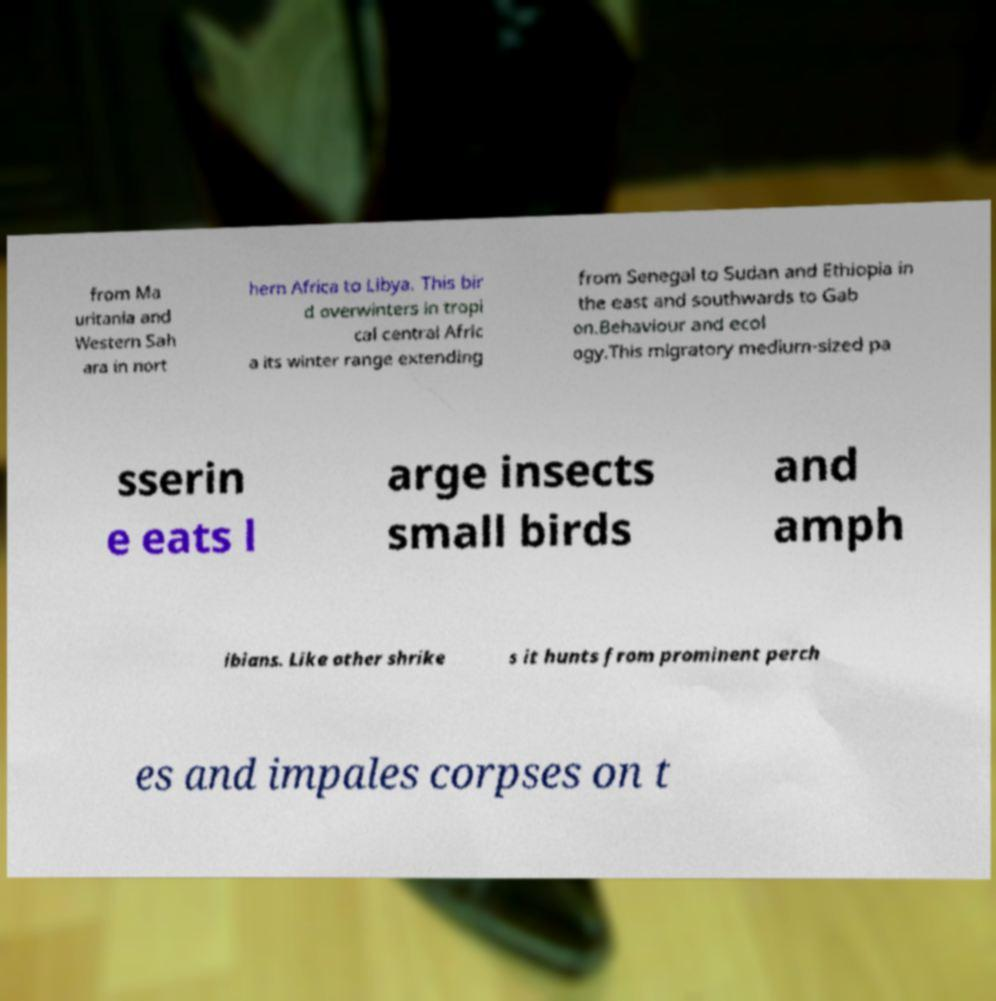Can you accurately transcribe the text from the provided image for me? from Ma uritania and Western Sah ara in nort hern Africa to Libya. This bir d overwinters in tropi cal central Afric a its winter range extending from Senegal to Sudan and Ethiopia in the east and southwards to Gab on.Behaviour and ecol ogy.This migratory medium-sized pa sserin e eats l arge insects small birds and amph ibians. Like other shrike s it hunts from prominent perch es and impales corpses on t 